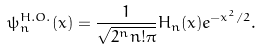<formula> <loc_0><loc_0><loc_500><loc_500>\psi ^ { H . O . } _ { n } ( x ) = \frac { 1 } { \sqrt { 2 ^ { n } n ! \pi } } H _ { n } ( x ) e ^ { - x ^ { 2 } / 2 } .</formula> 